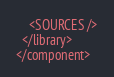<code> <loc_0><loc_0><loc_500><loc_500><_XML_>    <SOURCES />
  </library>
</component></code> 